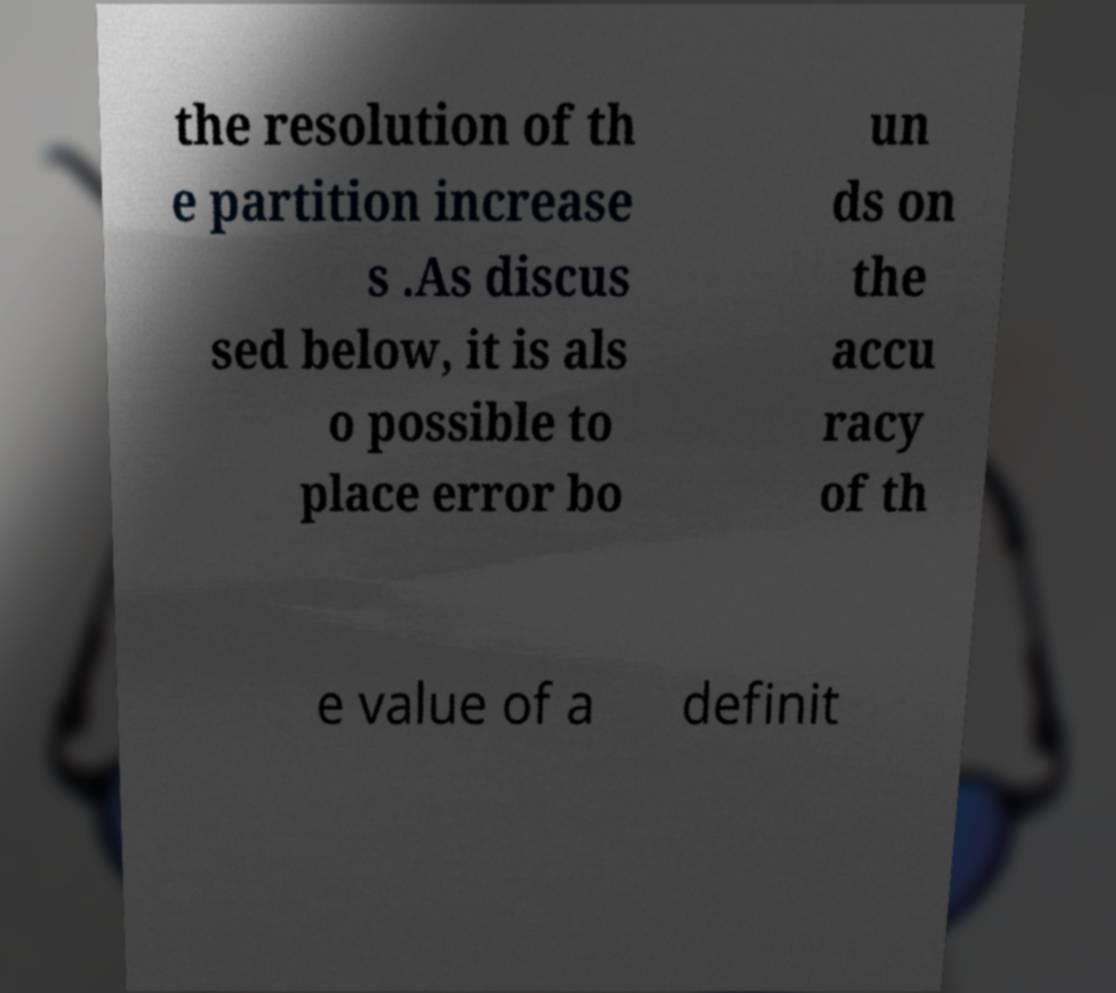Could you extract and type out the text from this image? the resolution of th e partition increase s .As discus sed below, it is als o possible to place error bo un ds on the accu racy of th e value of a definit 